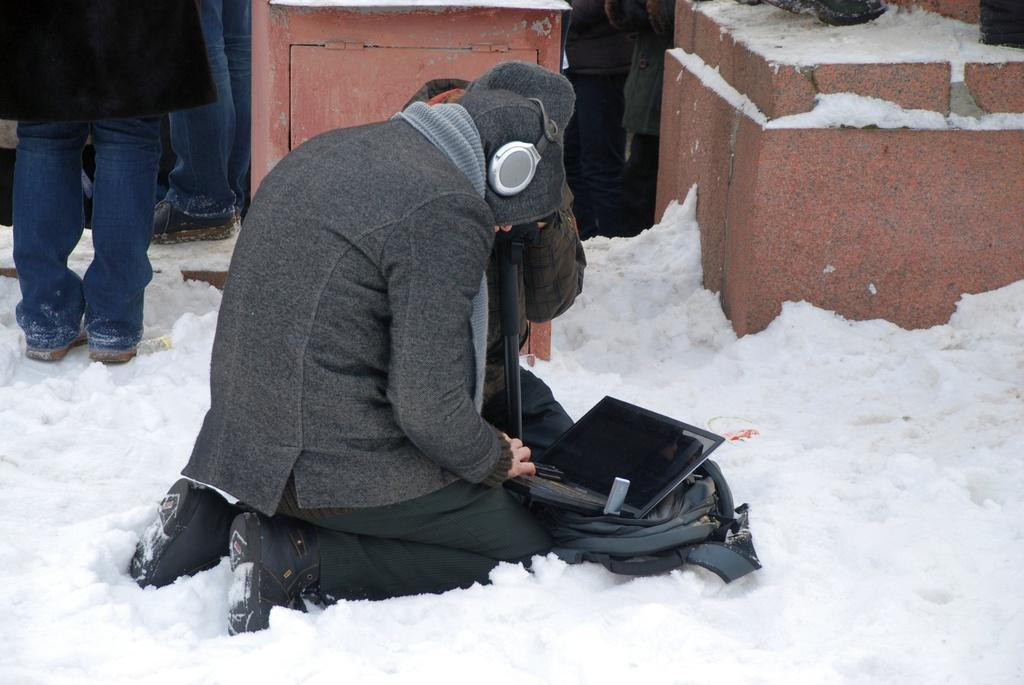What is the main subject of the image? There is a person sitting in the center of the image. What is the person sitting on? The person is sitting on snow. What is the person doing while sitting on the snow? The person is using a laptop. What can be seen in the background of the image? In the background, there are legs visible. Are there any trees visible in the image? No, there are no trees visible in the image. Can you see a tiger in the image? No, there is no tiger present in the image. 